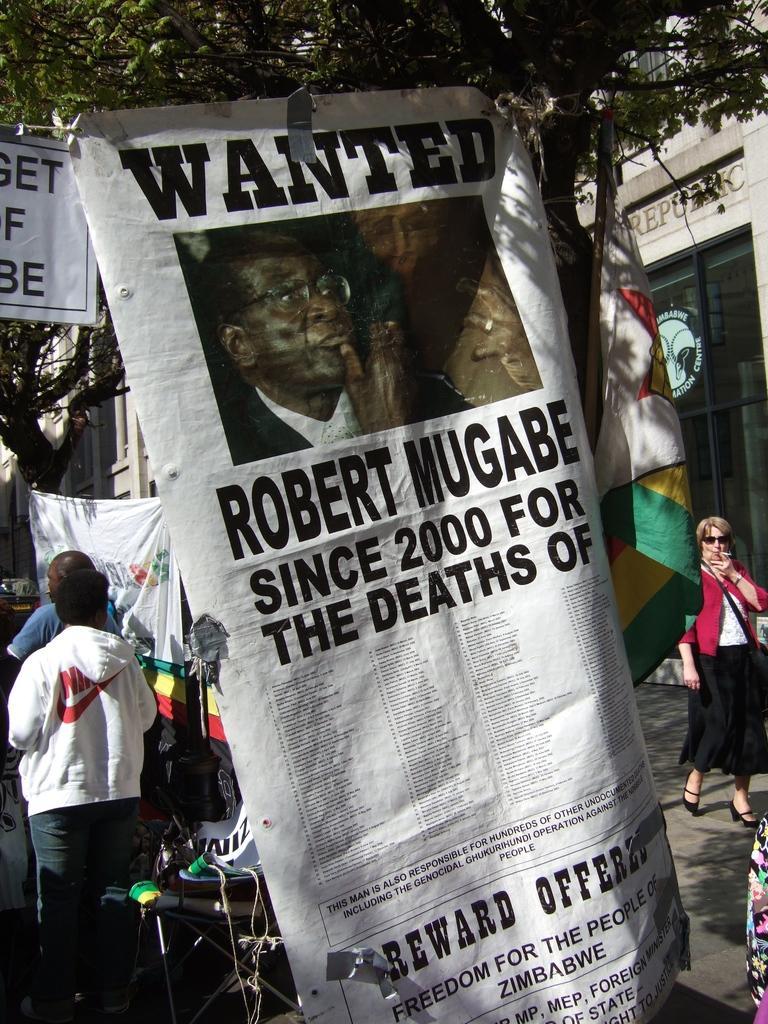Can you describe this image briefly? In the image there is a wanted poster attached to a tree and around that poster there are some people, flags and on the right side there is a building. 